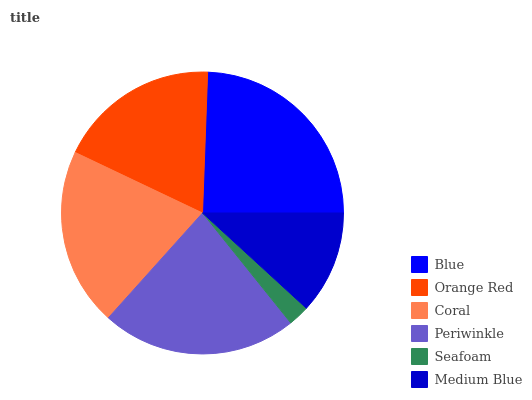Is Seafoam the minimum?
Answer yes or no. Yes. Is Blue the maximum?
Answer yes or no. Yes. Is Orange Red the minimum?
Answer yes or no. No. Is Orange Red the maximum?
Answer yes or no. No. Is Blue greater than Orange Red?
Answer yes or no. Yes. Is Orange Red less than Blue?
Answer yes or no. Yes. Is Orange Red greater than Blue?
Answer yes or no. No. Is Blue less than Orange Red?
Answer yes or no. No. Is Coral the high median?
Answer yes or no. Yes. Is Orange Red the low median?
Answer yes or no. Yes. Is Orange Red the high median?
Answer yes or no. No. Is Coral the low median?
Answer yes or no. No. 